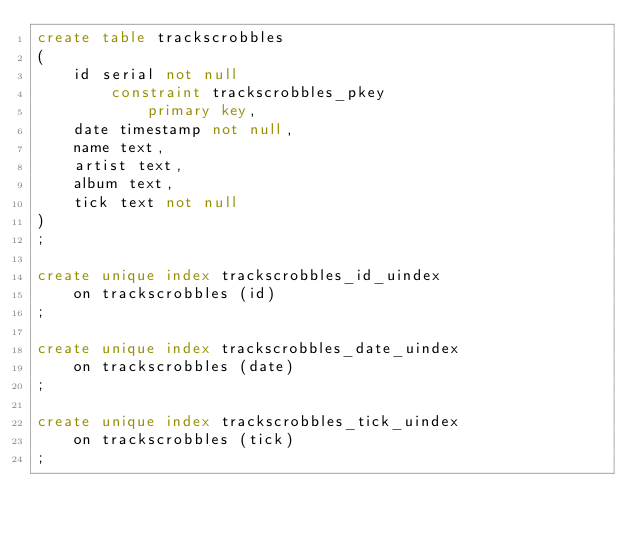<code> <loc_0><loc_0><loc_500><loc_500><_SQL_>create table trackscrobbles
(
	id serial not null
		constraint trackscrobbles_pkey
			primary key,
	date timestamp not null,
	name text,
	artist text,
	album text,
	tick text not null
)
;

create unique index trackscrobbles_id_uindex
	on trackscrobbles (id)
;

create unique index trackscrobbles_date_uindex
	on trackscrobbles (date)
;

create unique index trackscrobbles_tick_uindex
	on trackscrobbles (tick)
;

</code> 